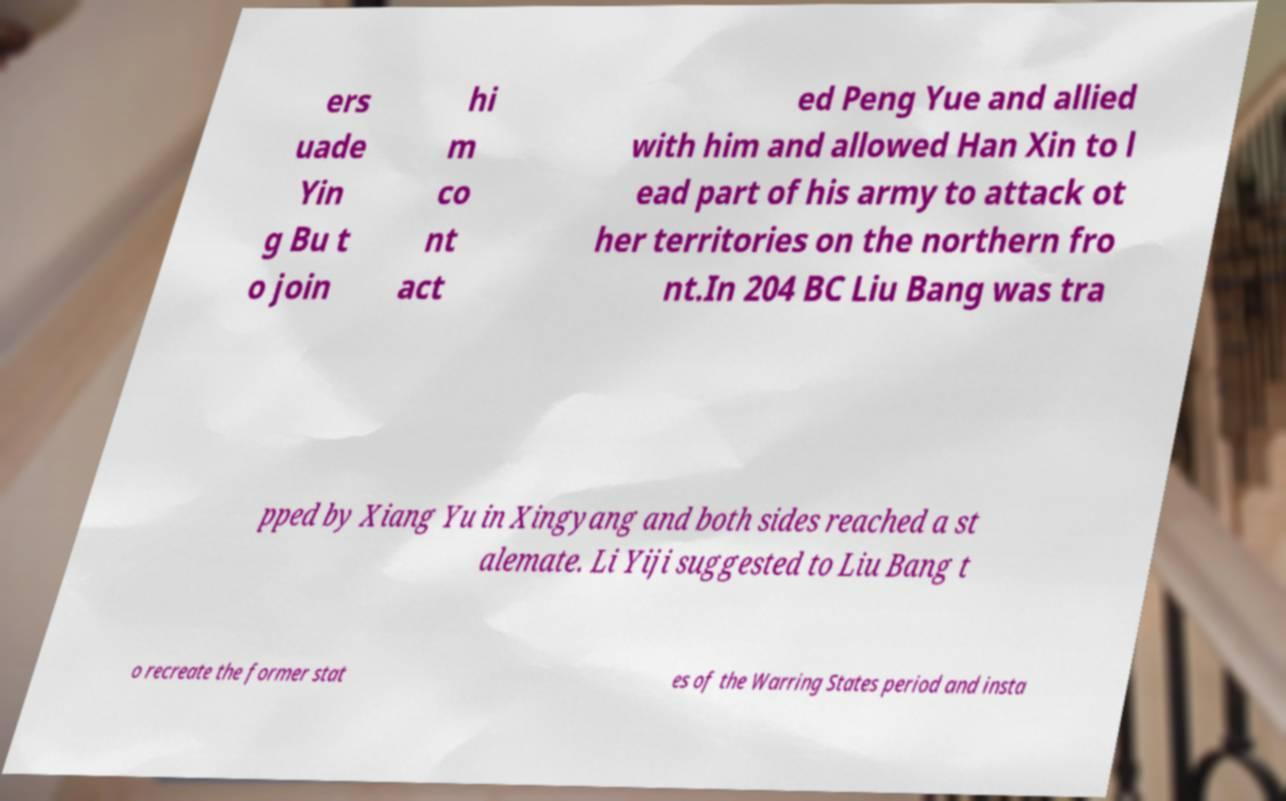Please read and relay the text visible in this image. What does it say? ers uade Yin g Bu t o join hi m co nt act ed Peng Yue and allied with him and allowed Han Xin to l ead part of his army to attack ot her territories on the northern fro nt.In 204 BC Liu Bang was tra pped by Xiang Yu in Xingyang and both sides reached a st alemate. Li Yiji suggested to Liu Bang t o recreate the former stat es of the Warring States period and insta 